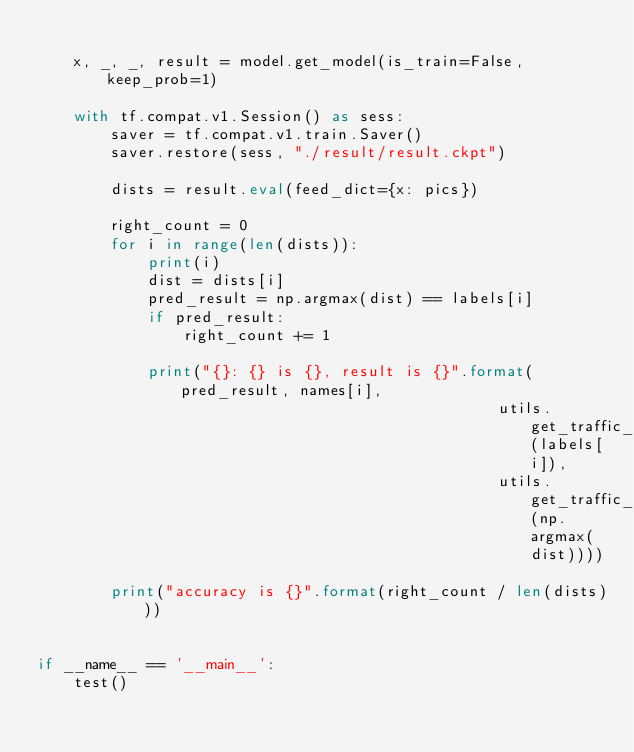<code> <loc_0><loc_0><loc_500><loc_500><_Python_>
    x, _, _, result = model.get_model(is_train=False, keep_prob=1)

    with tf.compat.v1.Session() as sess:
        saver = tf.compat.v1.train.Saver()
        saver.restore(sess, "./result/result.ckpt")

        dists = result.eval(feed_dict={x: pics})

        right_count = 0
        for i in range(len(dists)):
            print(i)
            dist = dists[i]
            pred_result = np.argmax(dist) == labels[i]
            if pred_result:
                right_count += 1

            print("{}: {} is {}, result is {}".format(pred_result, names[i],
                                                  utils.get_traffic_name(labels[i]),
                                                  utils.get_traffic_name(np.argmax(dist))))

        print("accuracy is {}".format(right_count / len(dists)))


if __name__ == '__main__':
    test()</code> 